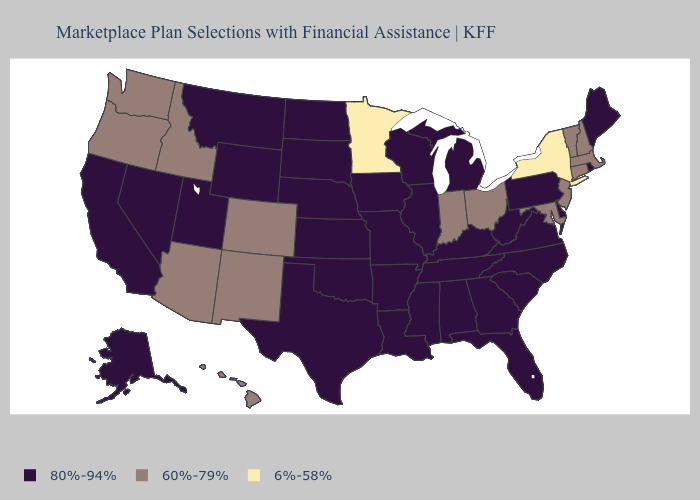What is the lowest value in the USA?
Answer briefly. 6%-58%. Does South Dakota have the lowest value in the MidWest?
Write a very short answer. No. Among the states that border Virginia , does Maryland have the lowest value?
Give a very brief answer. Yes. What is the value of Virginia?
Concise answer only. 80%-94%. How many symbols are there in the legend?
Concise answer only. 3. Does Colorado have the highest value in the USA?
Write a very short answer. No. Does Washington have the lowest value in the USA?
Answer briefly. No. Does North Dakota have the highest value in the MidWest?
Answer briefly. Yes. What is the value of Michigan?
Keep it brief. 80%-94%. Is the legend a continuous bar?
Keep it brief. No. What is the value of North Carolina?
Concise answer only. 80%-94%. What is the value of Maine?
Write a very short answer. 80%-94%. What is the value of Indiana?
Concise answer only. 60%-79%. What is the value of South Dakota?
Answer briefly. 80%-94%. Does the map have missing data?
Be succinct. No. 